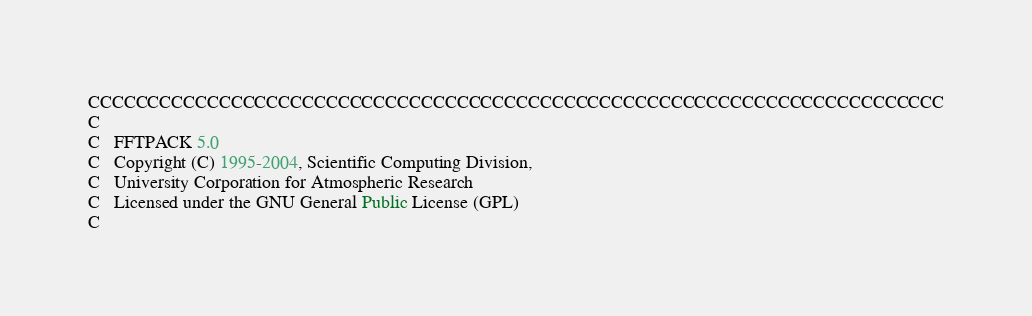Convert code to text. <code><loc_0><loc_0><loc_500><loc_500><_FORTRAN_>CCCCCCCCCCCCCCCCCCCCCCCCCCCCCCCCCCCCCCCCCCCCCCCCCCCCCCCCCCCCCCCCCCCCCCCC
C
C   FFTPACK 5.0 
C   Copyright (C) 1995-2004, Scientific Computing Division,
C   University Corporation for Atmospheric Research
C   Licensed under the GNU General Public License (GPL)
C</code> 